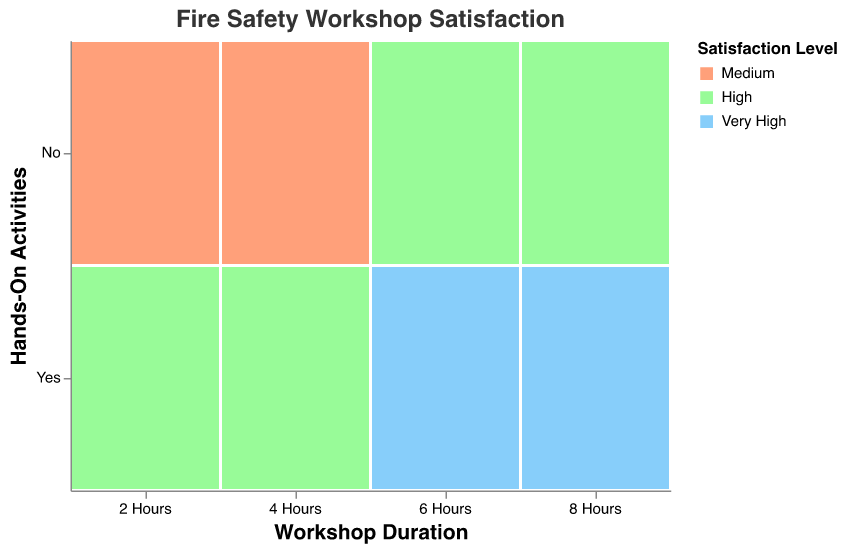How many participants are there in the workshop with a duration of 6 hours and hands-on activities? Look for the data point where "Workshop Duration" is 6 hours and "Hands-On Activities" is "Yes." The number of participants associated with this data point is 55.
Answer: 55 Which satisfaction level is associated with the highest number of participants in the 4-hour workshops? Examine the data points for workshops with "Workshop Duration" of 4 hours. The satisfaction levels are "High" with 60 participants and "Medium" with 35 participants. "High" has the most participants.
Answer: High What are the satisfaction levels observed in the workshops without hands-on activities? Identify the data points where "Hands-On Activities" is "No." The satisfaction levels listed are "Medium" and "High."
Answer: Medium and High Which duration, hands-on or not, and satisfaction level combination has the smallest number of participants? Look at each data point and compare the number of participants. The smallest number is 25 for the 8-hour workshop without hands-on activities and a "High" satisfaction level.
Answer: 25 What is the combined number of participants in the workshops that are 2 hours long? Sum the number of participants for the 2-hour workshops with hands-on activities (45) and without (30). The total is 45 + 30 = 75.
Answer: 75 Do longer workshop durations consistently show higher satisfaction levels? Compare the satisfaction levels for different workshop durations. Workshops of 6 and 8 hours have "Very High" satisfaction with hands-on activities, but even without hands-on activities, 6 hours have "High" and 8 hours also have "High" satisfaction. The trend suggests higher duration tends to be associated with higher satisfaction.
Answer: Yes, generally How does the presence of hands-on activities affect participant satisfaction in 6-hour workshops? Compare the satisfaction levels for 6-hour workshops with and without hands-on activities. With hands-on activities, satisfaction is "Very High." Without hands-on activities, satisfaction is "High."
Answer: Hands-on activities improve satisfaction Which combination of workshop duration and hands-on activities yields the "Very High" satisfaction level? Identify the data points with "Very High" satisfaction. They are 6-hour and 8-hour workshops with hands-on activities.
Answer: 6 hours and 8 hours with hands-on activities What is the difference in participants between 4-hour workshops with and without hands-on activities? Subtract the number of participants in the 4-hour workshop without hands-on activities (35) from the number with hands-on activities (60). The difference is 60 - 35 = 25.
Answer: 25 Which satisfaction level has the largest number of participants in total for all workshops? Sum participants for each satisfaction level across all workshops. Medium: 30 + 35 = 65 participants; High: 45 + 60 + 40 + 25 = 170 participants; Very High: 55 + 50 = 105 participants. "High" has the largest total.
Answer: High 